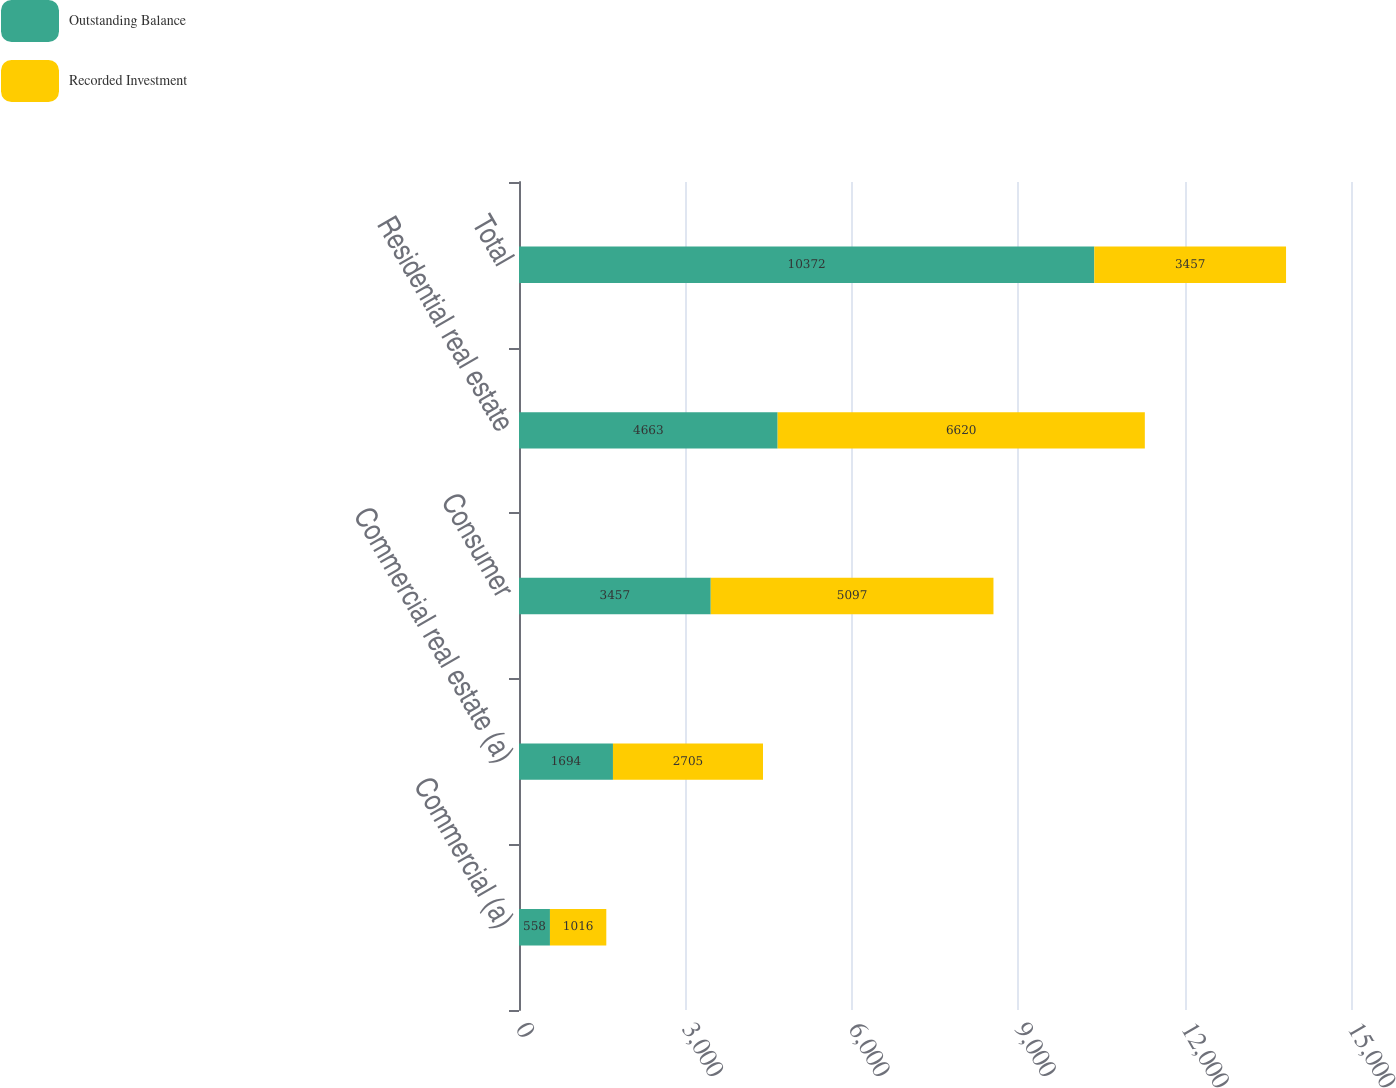Convert chart. <chart><loc_0><loc_0><loc_500><loc_500><stacked_bar_chart><ecel><fcel>Commercial (a)<fcel>Commercial real estate (a)<fcel>Consumer<fcel>Residential real estate<fcel>Total<nl><fcel>Outstanding Balance<fcel>558<fcel>1694<fcel>3457<fcel>4663<fcel>10372<nl><fcel>Recorded Investment<fcel>1016<fcel>2705<fcel>5097<fcel>6620<fcel>3457<nl></chart> 